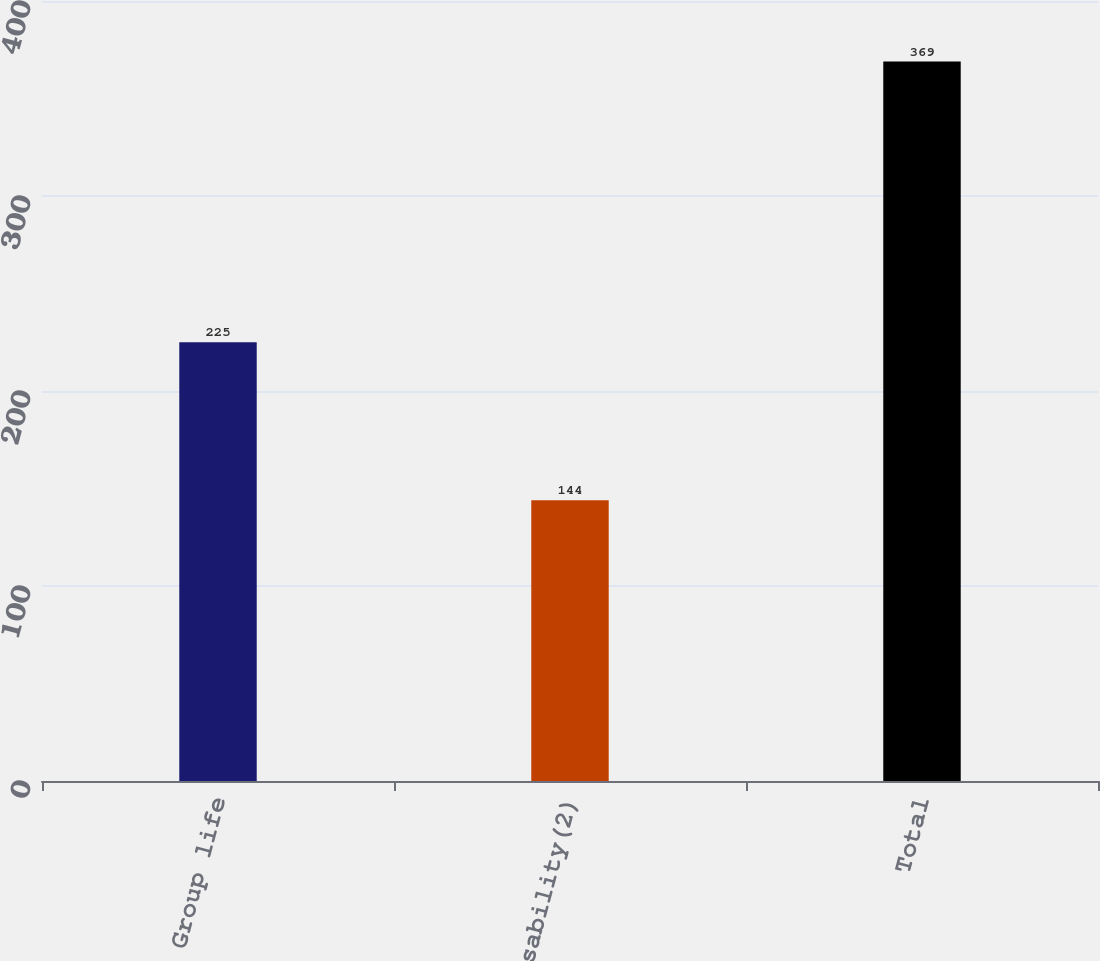<chart> <loc_0><loc_0><loc_500><loc_500><bar_chart><fcel>Group life<fcel>Group disability(2)<fcel>Total<nl><fcel>225<fcel>144<fcel>369<nl></chart> 